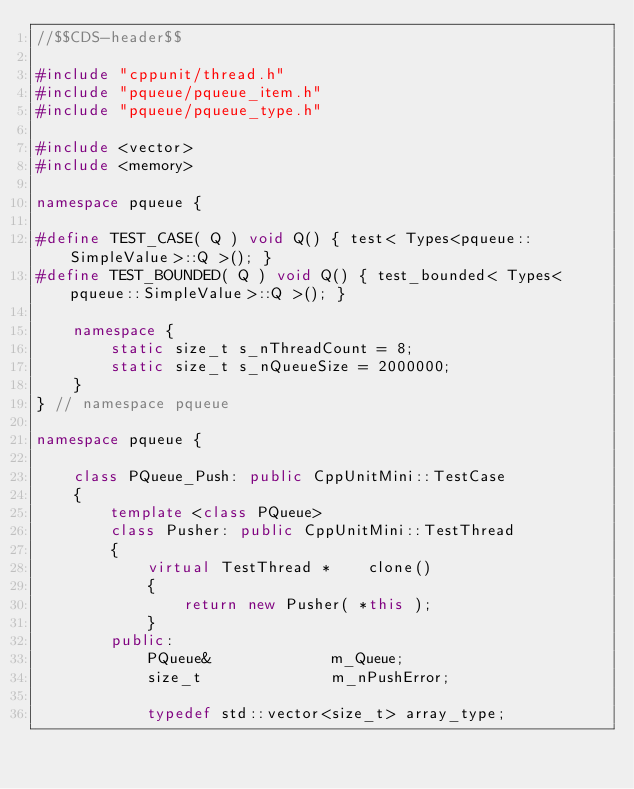Convert code to text. <code><loc_0><loc_0><loc_500><loc_500><_C++_>//$$CDS-header$$

#include "cppunit/thread.h"
#include "pqueue/pqueue_item.h"
#include "pqueue/pqueue_type.h"

#include <vector>
#include <memory>

namespace pqueue {

#define TEST_CASE( Q ) void Q() { test< Types<pqueue::SimpleValue>::Q >(); }
#define TEST_BOUNDED( Q ) void Q() { test_bounded< Types<pqueue::SimpleValue>::Q >(); }

    namespace {
        static size_t s_nThreadCount = 8;
        static size_t s_nQueueSize = 2000000;
    }
} // namespace pqueue

namespace pqueue {

    class PQueue_Push: public CppUnitMini::TestCase
    {
        template <class PQueue>
        class Pusher: public CppUnitMini::TestThread
        {
            virtual TestThread *    clone()
            {
                return new Pusher( *this );
            }
        public:
            PQueue&             m_Queue;
            size_t              m_nPushError;

            typedef std::vector<size_t> array_type;</code> 